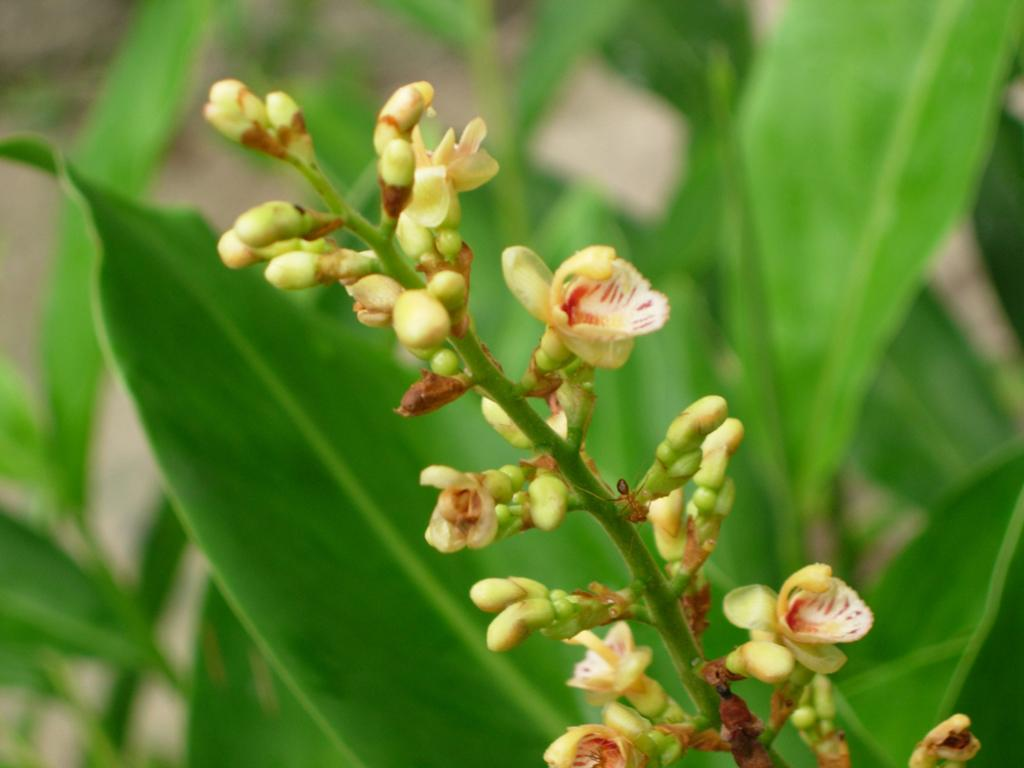What is present on the plant in the image? There is an insect on a plant in the image. What can be seen in the background of the image? There are leaves visible in the background of the image. What type of spark can be seen coming from the insect in the image? There is no spark present in the image; it features an insect on a plant with leaves in the background. 